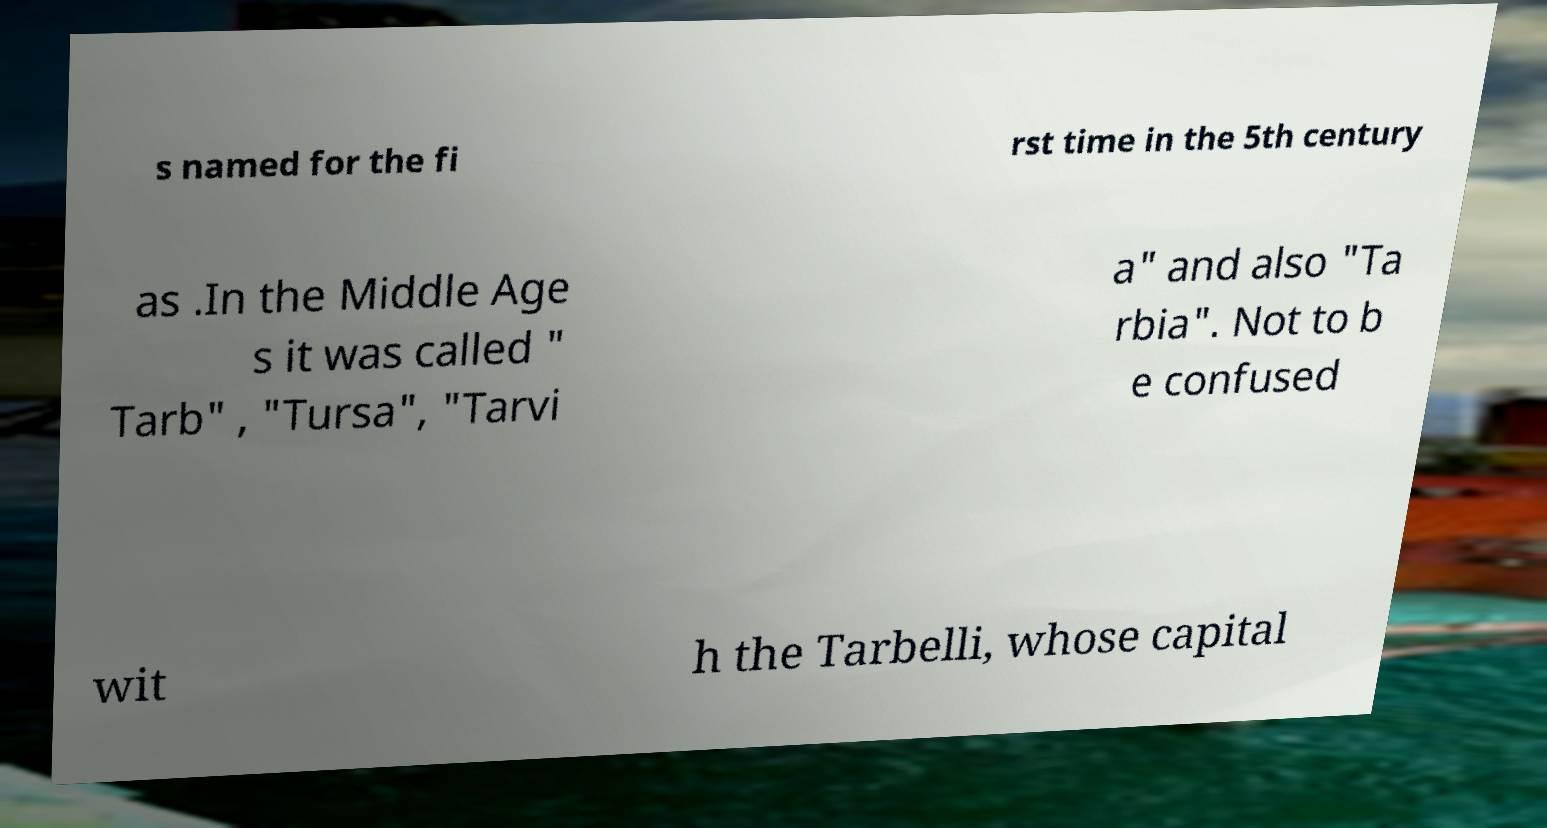Could you assist in decoding the text presented in this image and type it out clearly? s named for the fi rst time in the 5th century as .In the Middle Age s it was called " Tarb" , "Tursa", "Tarvi a" and also "Ta rbia". Not to b e confused wit h the Tarbelli, whose capital 